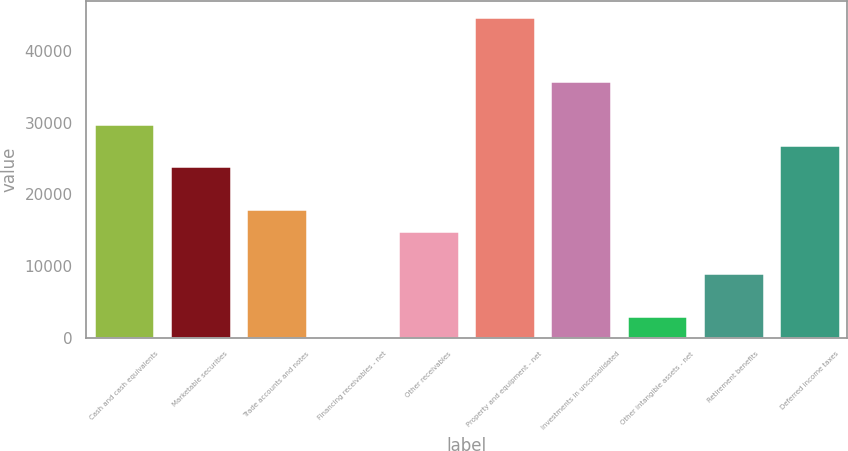Convert chart to OTSL. <chart><loc_0><loc_0><loc_500><loc_500><bar_chart><fcel>Cash and cash equivalents<fcel>Marketable securities<fcel>Trade accounts and notes<fcel>Financing receivables - net<fcel>Other receivables<fcel>Property and equipment - net<fcel>Investments in unconsolidated<fcel>Other intangible assets - net<fcel>Retirement benefits<fcel>Deferred income taxes<nl><fcel>29876.4<fcel>23904.4<fcel>17932.4<fcel>16.5<fcel>14946.5<fcel>44806.3<fcel>35848.4<fcel>3002.49<fcel>8974.47<fcel>26890.4<nl></chart> 